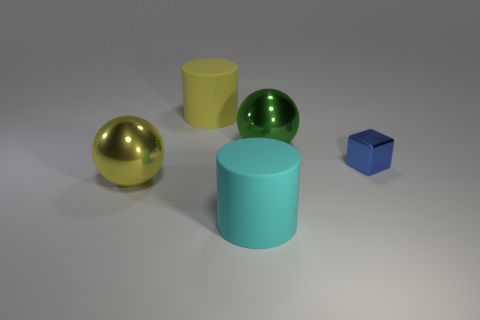Add 4 cylinders. How many objects exist? 9 Subtract all blocks. How many objects are left? 4 Subtract 1 cylinders. How many cylinders are left? 1 Subtract all big blue rubber balls. Subtract all green shiny balls. How many objects are left? 4 Add 4 large yellow rubber cylinders. How many large yellow rubber cylinders are left? 5 Add 1 purple shiny things. How many purple shiny things exist? 1 Subtract 0 red spheres. How many objects are left? 5 Subtract all brown cubes. Subtract all purple spheres. How many cubes are left? 1 